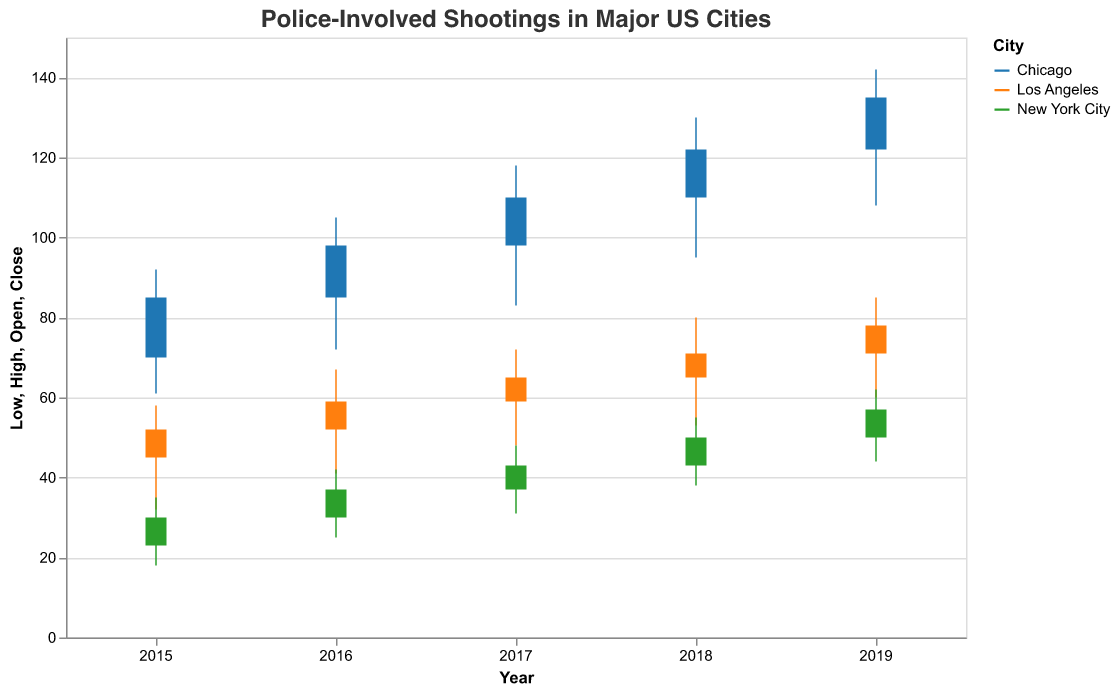What is the highest recorded number of police-involved shootings in Chicago in the given period? Refer to the figure and identify the highest value in Chicago. The highest spike on the graph for Chicago hits 142 in 2019.
Answer: 142 Which city had the lowest recorded number of police-involved shootings in 2015? Look at the 'Low' values for each city in 2015. The lowest 'Low' value is 18 for New York City in 2015.
Answer: New York City How does the trend of police-involved shootings from 2015 to 2019 compare between Los Angeles and New York City? For this comparison, observe the closing values from 2015 to 2019 for both cities. Los Angeles increases from 52 to 78, while New York City rises from 30 to 57, showing that both cities have an increasing trend but the absolute numbers in Los Angeles are higher.
Answer: Both increasing, higher in Los Angeles How much did the number of police-involved shootings in New York City increase from 2015 to 2019? Subtract the 'Close' value of 2015 from the 'Close' value of 2019 for New York City. 57 - 30 = 27
Answer: 27 Between 2018 and 2019, which city had the largest increase in police-involved shootings? Calculate the difference in 'Close' values for all cities between 2018 and 2019. For Chicago, it’s 135 - 122 = 13; for Los Angeles, it’s 78 - 71 = 7; for New York City, it’s 57 - 50 = 7. Chicago has the largest increase.
Answer: Chicago Which city had the most consistent number of police-involved shootings over the years 2015-2019, considering the 'Low' values? Compare the range of 'Low' values for each city. New York City moves from 18 to 44 (a range of 26), Los Angeles moves from 32 to 60 (a range of 28), and Chicago moves from 61 to 108 (a range of 47). New York City shows the smallest range, indicating the most consistency.
Answer: New York City What was the opening value for police-involved shootings in Chicago in 2017? Look at the 'Open' values column for Chicago in the 2017 row. Chicago's opening value in 2017 was 98.
Answer: 98 In which year did Los Angeles experience the largest spread (difference between High and Low values) in police-involved shootings? Subtract 'Low' from 'High' for each year in Los Angeles. The spreads are calculated as follows: 2015 (58-32)=26, 2016 (67-41)=26, 2017 (72-48)=24, 2018 (80-53)=27, 2019 (85-60)=25. The largest spread occurred in 2018 with a value of 27.
Answer: 2018 